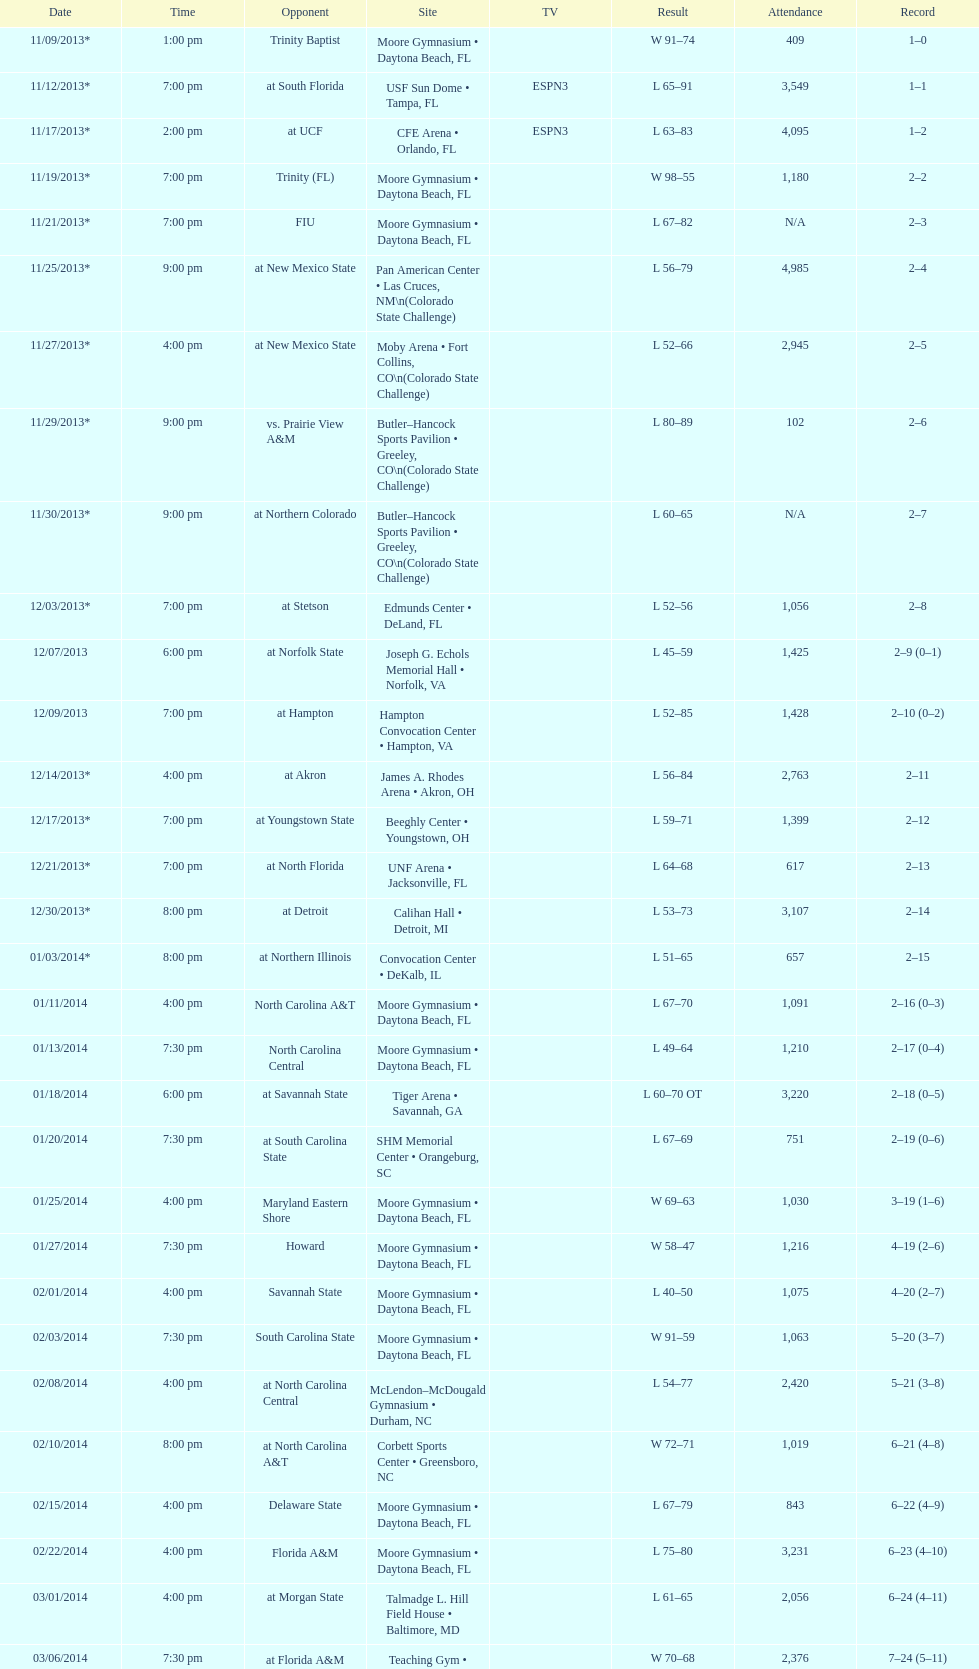Between fiu and northern colorado, which game occurred at a later time during the night? Northern Colorado. 